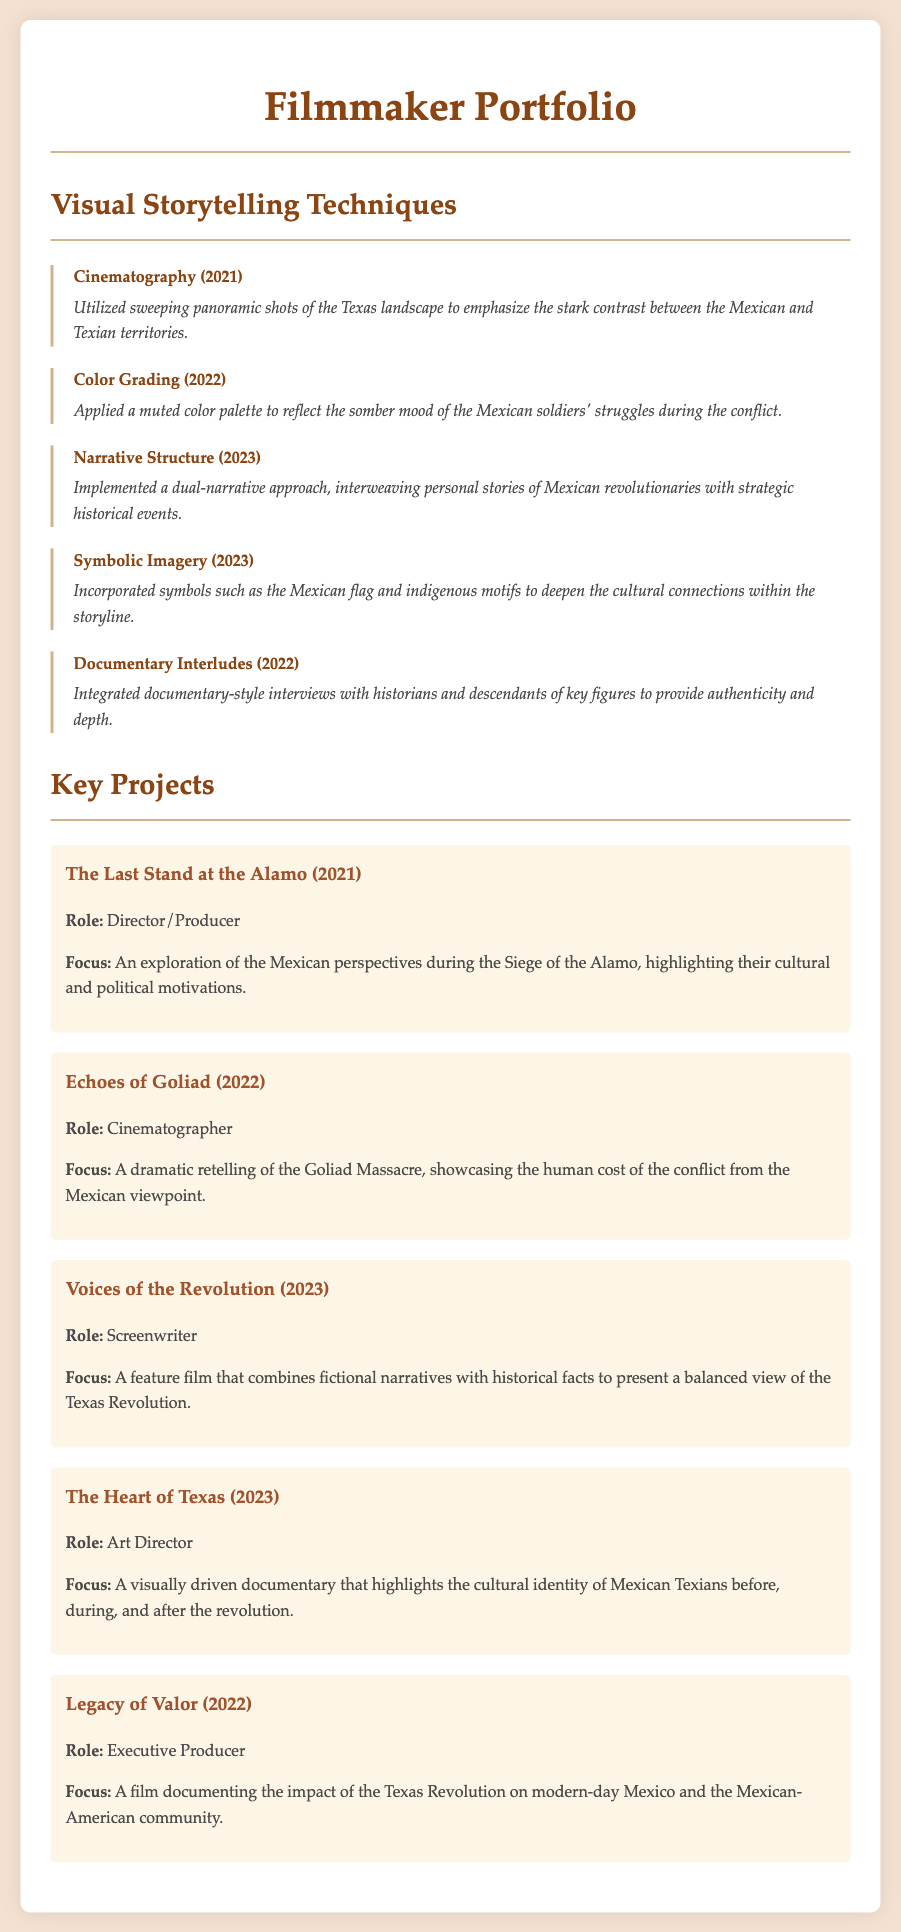What is the title of the portfolio? The title of the portfolio is "Filmmaker Portfolio" as stated in the document.
Answer: Filmmaker Portfolio What year was the cinematography technique used? The cinematography technique was utilized in 2021, as mentioned in the document.
Answer: 2021 What is the focus of the project "The Last Stand at the Alamo"? The focus of the project is an exploration of the Mexican perspectives during the Siege of the Alamo.
Answer: Exploration of the Mexican perspectives during the Siege of the Alamo Which technique uses interviews with historians? The technique that incorporates interviews is "Documentary Interludes" as described in the document.
Answer: Documentary Interludes How many key projects are listed in the document? The document lists a total of five key projects under the Key Projects section.
Answer: 5 What is the role of the filmmaker in "Voices of the Revolution"? The role of the filmmaker in this project is listed as Screenwriter.
Answer: Screenwriter What technique was used to reflect the somber mood of the soldiers? The technique used for this purpose is Color Grading as noted in the document.
Answer: Color Grading What is the focus of the project "Echoes of Goliad"? The focus of this project is a dramatic retelling of the Goliad Massacre.
Answer: Dramatic retelling of the Goliad Massacre 